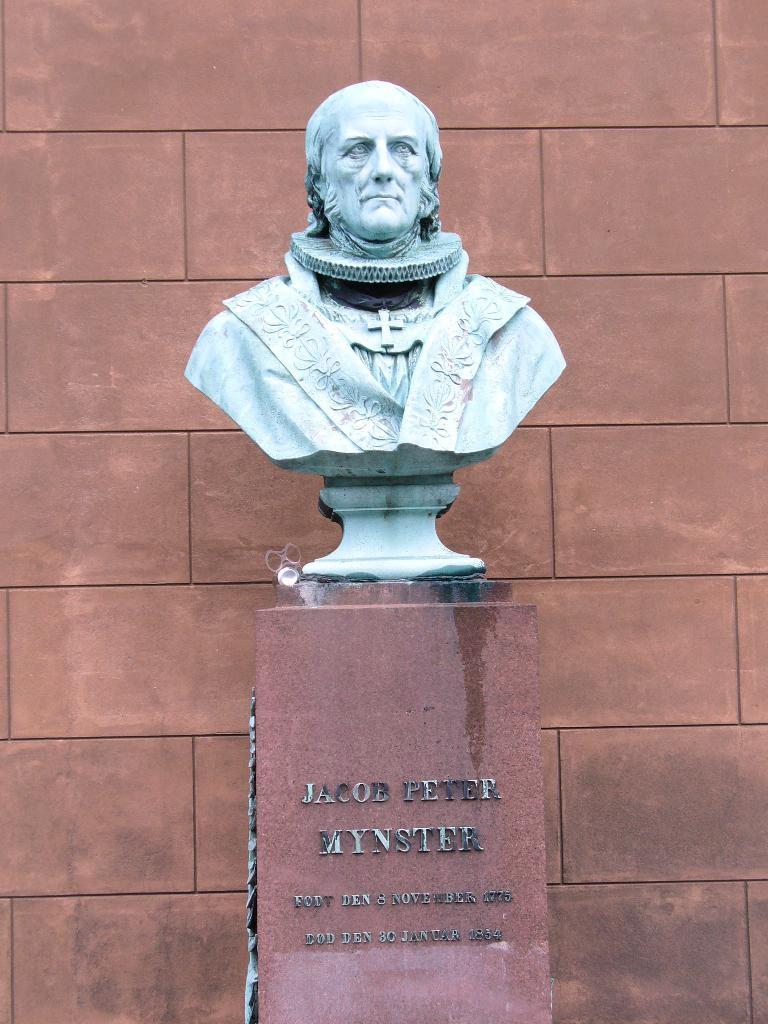What is the main subject in the image? There is a statue in the image. Where is the statue located? The statue is on a rock structure. What can be seen on the statue? There is text on the statue. What is visible in the background of the image? There is a wall in the background of the image. What type of business is being conducted by the horse in the image? There is no horse present in the image, so it is not possible to answer that question. 